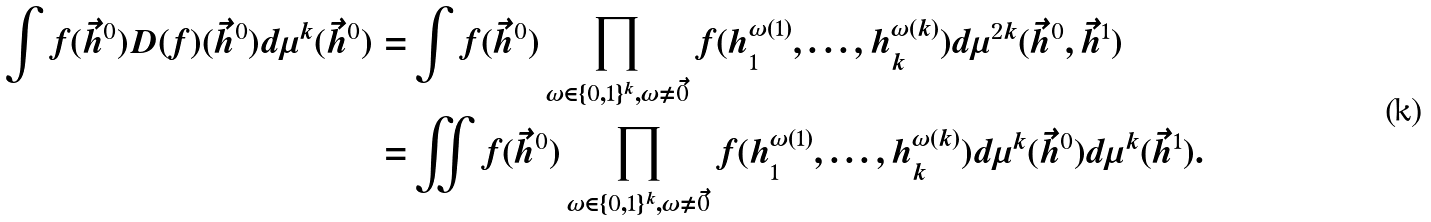Convert formula to latex. <formula><loc_0><loc_0><loc_500><loc_500>\int f ( \vec { h } ^ { 0 } ) D ( f ) ( \vec { h } ^ { 0 } ) d \mu ^ { k } ( \vec { h } ^ { 0 } ) = & \int f ( \vec { h } ^ { 0 } ) \prod _ { \omega \in \{ 0 , 1 \} ^ { k } , \omega \neq \vec { 0 } } f ( h ^ { \omega ( 1 ) } _ { 1 } , \dots , h ^ { \omega ( k ) } _ { k } ) d \mu ^ { 2 k } ( \vec { h } ^ { 0 } , \vec { h } ^ { 1 } ) \\ = & \iint f ( \vec { h } ^ { 0 } ) \prod _ { \omega \in \{ 0 , 1 \} ^ { k } , \omega \neq \vec { 0 } } f ( h ^ { \omega ( 1 ) } _ { 1 } , \dots , h ^ { \omega ( k ) } _ { k } ) d \mu ^ { k } ( \vec { h } ^ { 0 } ) d \mu ^ { k } ( \vec { h } ^ { 1 } ) . \\</formula> 